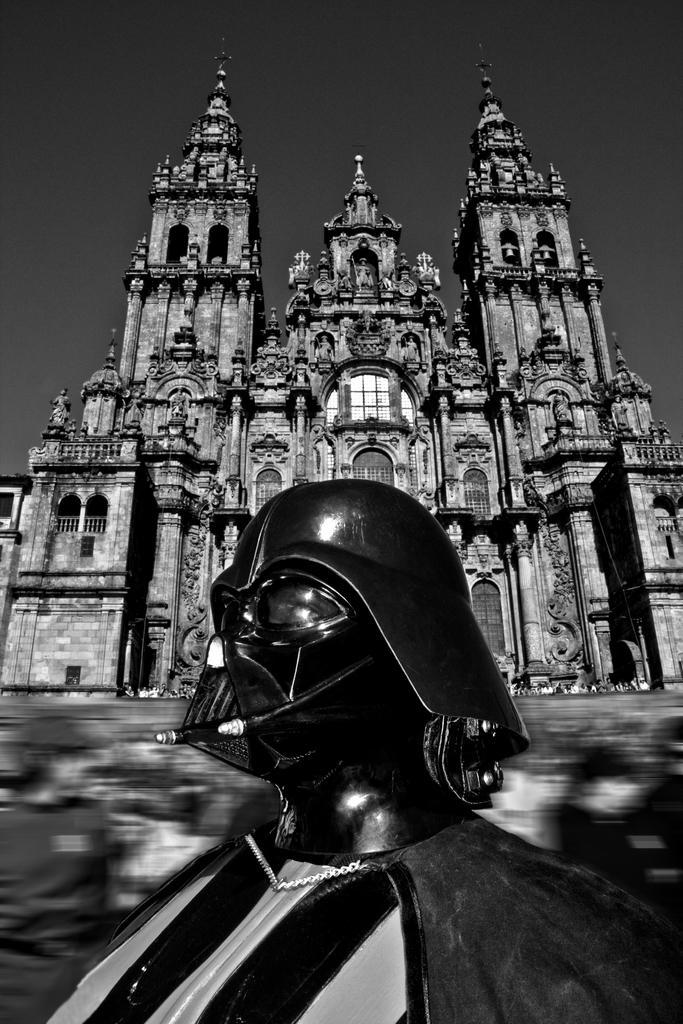Can you describe this image briefly? In this image I can see a black colour thing in the front. In the background I can see a building, the sky and I can also see this image is black and white in colour. 